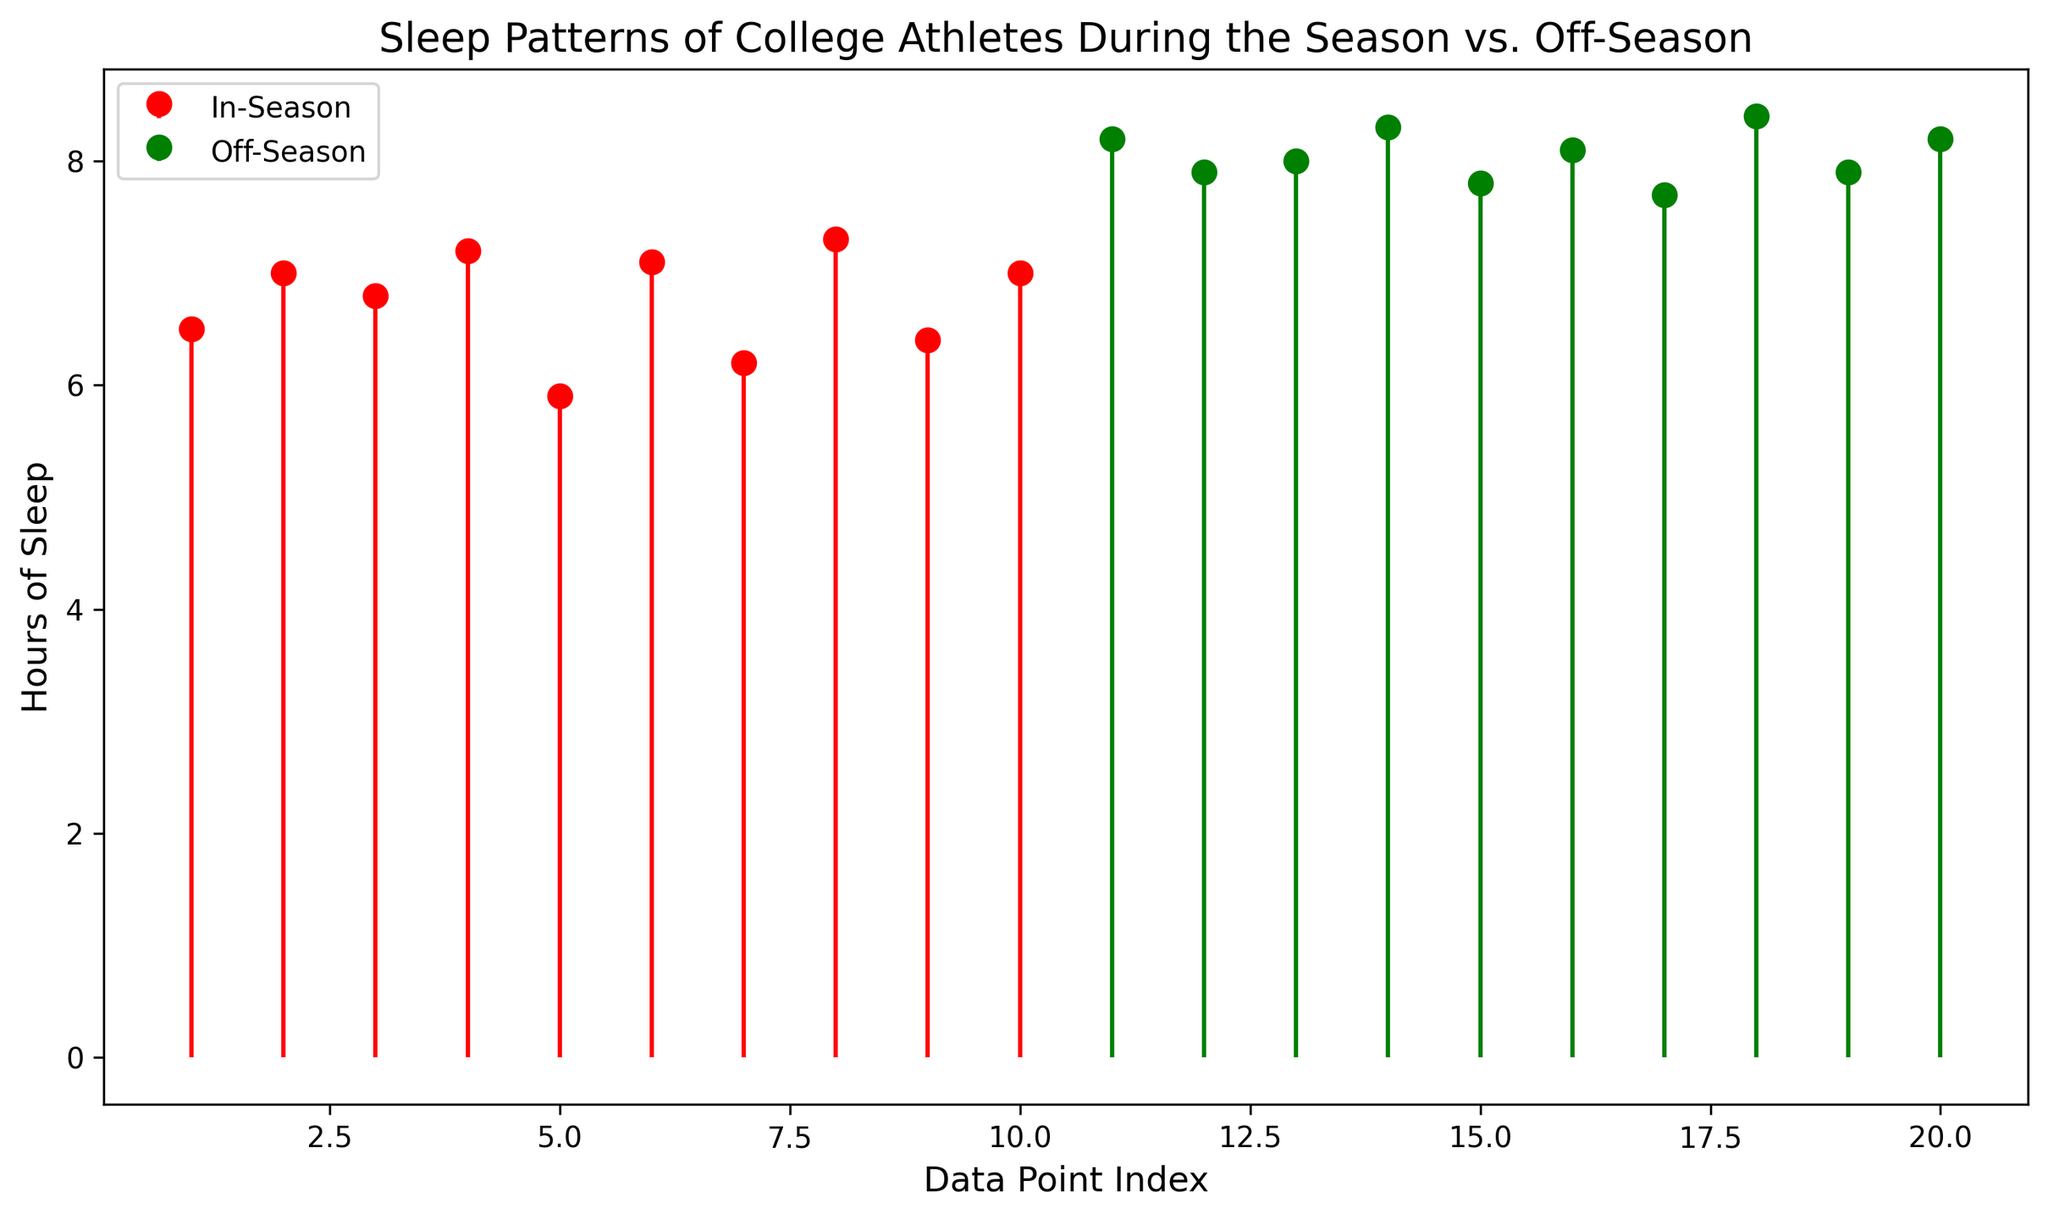How many data points are represented for both the In-Season and Off-Season sleep patterns? Count the number of stems and markers for both In-Season and Off-Season groups. Each stem represents one data point. The In-Season group has 10 markers, and the Off-Season group also has 10 markers.
Answer: Both groups have 10 data points each Which group shows a higher average number of hours of sleep? Calculate the average for both groups. The In-Season data points are 6.5, 7.0, 6.8, 7.2, 5.9, 7.1, 6.2, 7.3, 6.4, and 7.0. The Off-Season data points are 8.2, 7.9, 8.0, 8.3, 7.8, 8.1, 7.7, 8.4, 7.9, and 8.2. Summing up and dividing by the number of data points: In-Season average is (6.5 + 7.0 + 6.8 + 7.2 + 5.9 + 7.1 + 6.2 + 7.3 + 6.4 + 7.0) / 10 = 6.84, Off-Season average is (8.2 + 7.9 + 8.0 + 8.3 + 7.8 + 8.1 + 7.7 + 8.4 + 7.9 + 8.2) / 10 = 8.05.
Answer: Off-Season Is there any overlap in the range of sleeping hours between In-Season and Off-Season? If so, what is it? Identify the minimum and maximum values for both groups. In-Season ranges from 5.9 to 7.3 and Off-Season ranges from 7.7 to 8.4. There is no overlap since the highest In-Season value (7.3) is still lower than the lowest Off-Season value (7.7).
Answer: No overlap What is the maximum number of hours slept in the In-Season group? Observe the highest marker point in the red stem plot. The highest marker is at 7.3 hours.
Answer: 7.3 hours Compare the minimum number of hours slept between the two seasons. Which season has the lower minimum? Identify the lowest marker point in both the In-Season and Off-Season plots. The lowest marker for In-Season is 5.9 hours, and the lowest for Off-Season is 7.7 hours.
Answer: In-Season What visual difference is most noticeable between the two groups of data? Observe the overall height and number of values in each stem. The In-Season values are lower and more spread out, while the Off-Season values are higher and more clustered.
Answer: Off-Season values are higher and more clustered Which stem shows the longest stem line in the Off-Season group? Look for the longest green stem line in the Off-Season section. The longest stem line is at 8.4 hours.
Answer: 8.4 hours What is the median value of sleeping hours in the Off-Season group? Arrange the Off-Season data points in ascending order: 7.7, 7.8, 7.9, 7.9, 8.0, 8.1, 8.2, 8.2, 8.3, 8.4. The median is the average of the 5th and 6th values: (8.0 + 8.1) / 2 = 8.05.
Answer: 8.05 hours Between which two consecutive data points is the greatest difference in hours of sleep In-Season? Check the In-Season values for the largest absolute difference between consecutive numbers: 5.9, 6.2, 6.4, 6.5, 6.8, 7.0, 7.0, 7.1, 7.2, 7.3. The largest gap is between 7.2 and 5.9: 7.2 - 5.9 = 1.3.
Answer: 7.2 and 5.9 